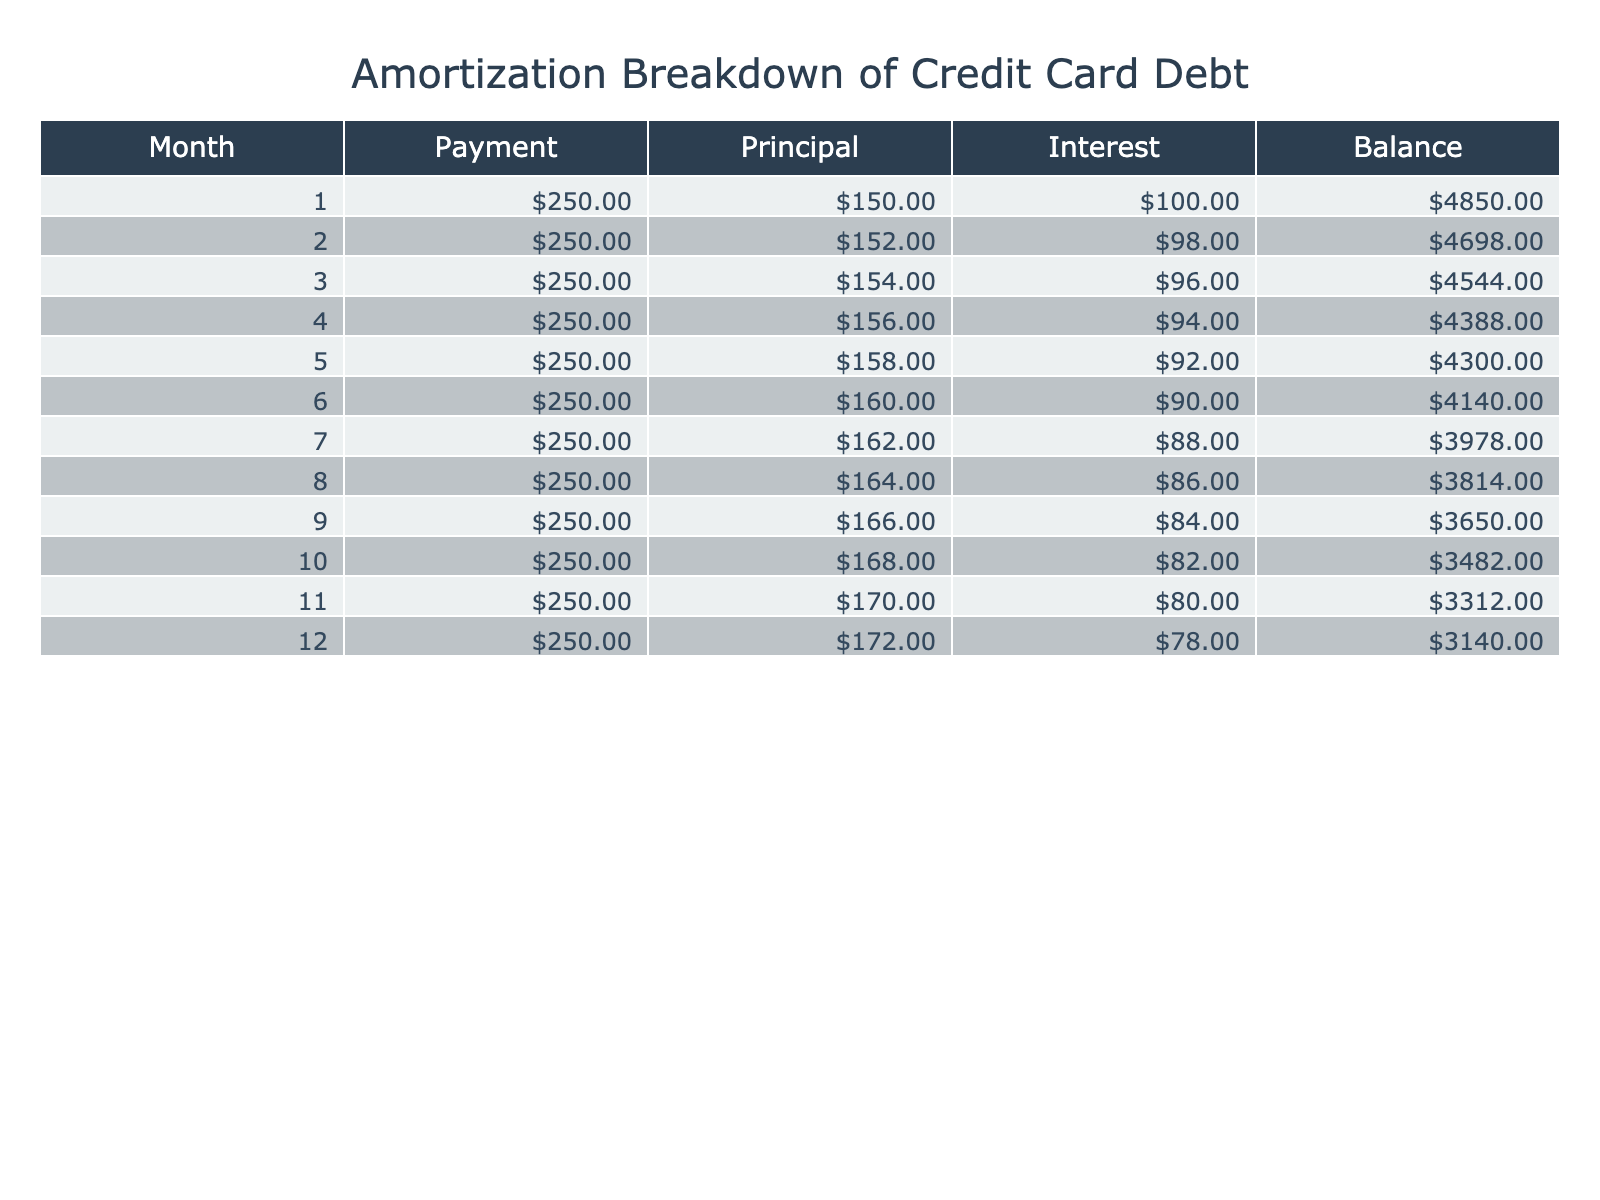What was the total payment made in month 5? The table shows a payment amount of 250.00 in month 5. Therefore, the total payment made in that month is 250.00.
Answer: 250.00 How much interest was paid in month 4? The interest for month 4 is listed in the table as 94.00. Thus, the interest paid in that month is 94.00.
Answer: 94.00 What is the average principal paid over the first three months? The principal amounts for the first three months are 150.00, 152.00, and 154.00. The sum is 150.00 + 152.00 + 154.00 = 456.00. Dividing by 3 gives an average of 456.00 / 3 = 152.00.
Answer: 152.00 Did the monthly payment amount remain constant throughout the year? Yes, the payment amount is consistently listed as 250.00 for all months in the table, indicating that it remained constant.
Answer: Yes In which month was the balance reduced to below 4000.00? Looking through the table, the balance first drops below 4000.00 after month 7, where the balance is 3978.00. Therefore, the month when the balance falls below 4000.00 is month 7.
Answer: 7 What is the total reduction in balance from month 1 to month 12? The balance in month 1 is 4850.00, and by month 12 it has reduced to 3140.00. The total reduction is 4850.00 - 3140.00 = 1710.00.
Answer: 1710.00 How much principal was paid over the first six months combined? The principal payments for the first six months are 150.00, 152.00, 154.00, 156.00, 158.00, and 160.00. Summing these gives 150.00 + 152.00 + 154.00 + 156.00 + 158.00 + 160.00 = 930.00.
Answer: 930.00 Did the interest paid decrease each month? Yes, the interest payments for the months decrease from 100.00 down to 78.00, showing a consistent decline each month.
Answer: Yes What was the total amount of interest paid across all months? The interest amounts for each month are cumulative: 100.00 + 98.00 + 96.00 + 94.00 + 92.00 + 90.00 + 88.00 + 86.00 + 84.00 + 82.00 + 80.00 + 78.00 = 1012.00. Therefore, the total interest paid is 1012.00.
Answer: 1012.00 